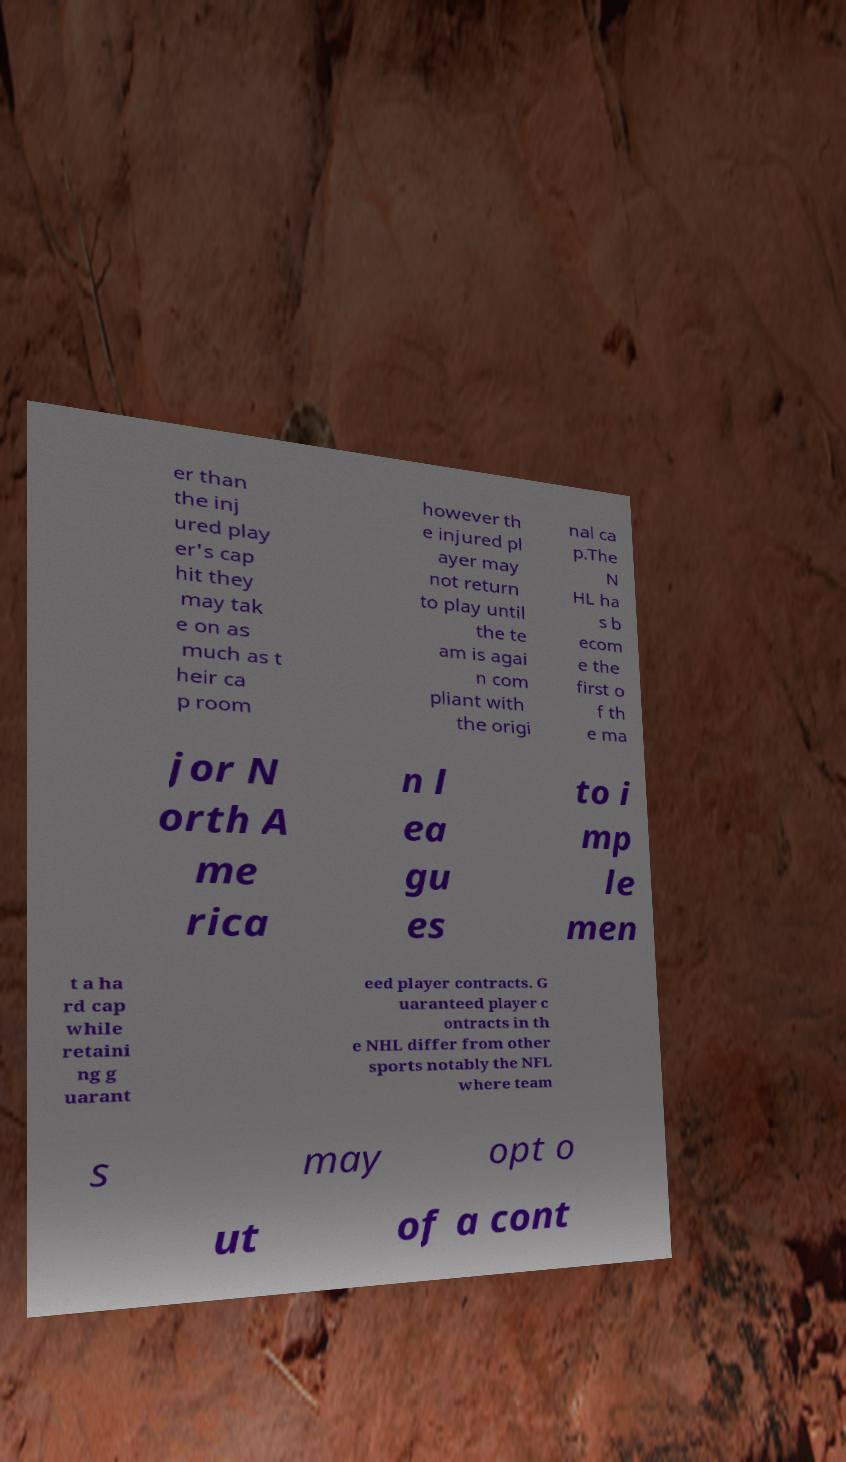For documentation purposes, I need the text within this image transcribed. Could you provide that? er than the inj ured play er's cap hit they may tak e on as much as t heir ca p room however th e injured pl ayer may not return to play until the te am is agai n com pliant with the origi nal ca p.The N HL ha s b ecom e the first o f th e ma jor N orth A me rica n l ea gu es to i mp le men t a ha rd cap while retaini ng g uarant eed player contracts. G uaranteed player c ontracts in th e NHL differ from other sports notably the NFL where team s may opt o ut of a cont 